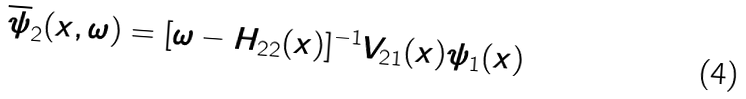Convert formula to latex. <formula><loc_0><loc_0><loc_500><loc_500>\overline { \psi } _ { 2 } ( x , \omega ) = [ \omega - H _ { 2 2 } ( x ) ] ^ { - 1 } V _ { 2 1 } ( x ) \psi _ { 1 } ( x )</formula> 